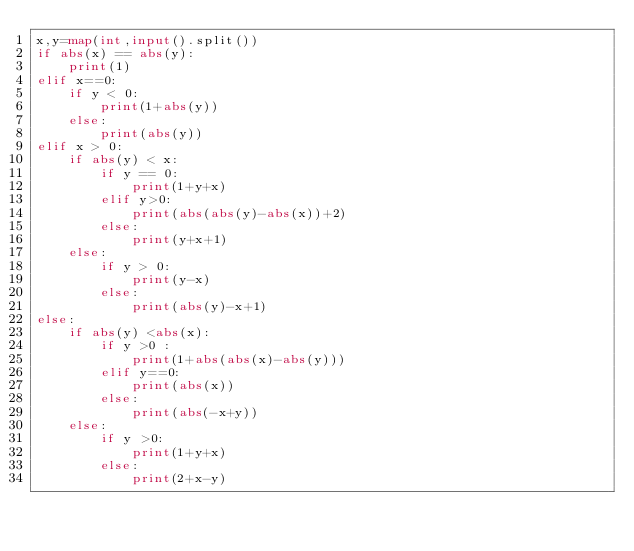<code> <loc_0><loc_0><loc_500><loc_500><_Python_>x,y=map(int,input().split())
if abs(x) == abs(y):
    print(1)
elif x==0:
    if y < 0:
        print(1+abs(y))
    else:
        print(abs(y))
elif x > 0:
    if abs(y) < x:
        if y == 0:
            print(1+y+x)
        elif y>0:
            print(abs(abs(y)-abs(x))+2)
        else:
            print(y+x+1)
    else:
        if y > 0:
            print(y-x)
        else:
            print(abs(y)-x+1)
else:
    if abs(y) <abs(x):
        if y >0 :
            print(1+abs(abs(x)-abs(y)))
        elif y==0:
            print(abs(x))
        else:
            print(abs(-x+y))
    else:
        if y >0:
            print(1+y+x)
        else:
            print(2+x-y)
</code> 